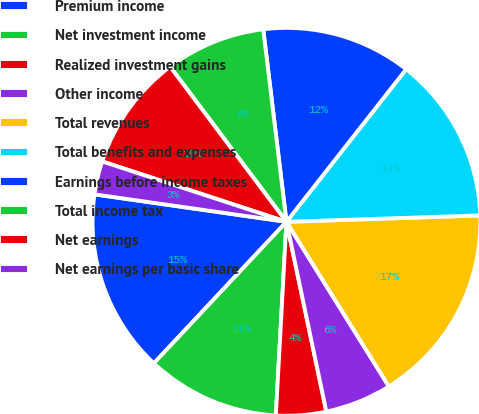Convert chart to OTSL. <chart><loc_0><loc_0><loc_500><loc_500><pie_chart><fcel>Premium income<fcel>Net investment income<fcel>Realized investment gains<fcel>Other income<fcel>Total revenues<fcel>Total benefits and expenses<fcel>Earnings before income taxes<fcel>Total income tax<fcel>Net earnings<fcel>Net earnings per basic share<nl><fcel>15.28%<fcel>11.11%<fcel>4.17%<fcel>5.56%<fcel>16.67%<fcel>13.89%<fcel>12.5%<fcel>8.33%<fcel>9.72%<fcel>2.78%<nl></chart> 